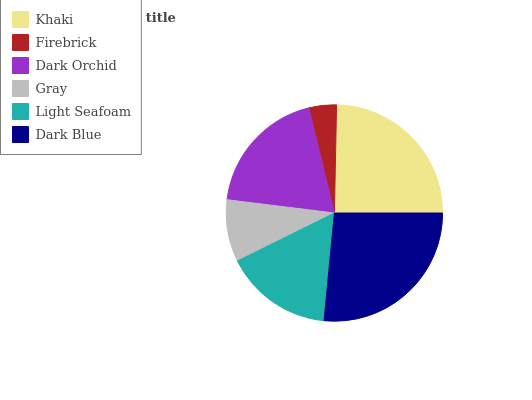Is Firebrick the minimum?
Answer yes or no. Yes. Is Dark Blue the maximum?
Answer yes or no. Yes. Is Dark Orchid the minimum?
Answer yes or no. No. Is Dark Orchid the maximum?
Answer yes or no. No. Is Dark Orchid greater than Firebrick?
Answer yes or no. Yes. Is Firebrick less than Dark Orchid?
Answer yes or no. Yes. Is Firebrick greater than Dark Orchid?
Answer yes or no. No. Is Dark Orchid less than Firebrick?
Answer yes or no. No. Is Dark Orchid the high median?
Answer yes or no. Yes. Is Light Seafoam the low median?
Answer yes or no. Yes. Is Gray the high median?
Answer yes or no. No. Is Dark Orchid the low median?
Answer yes or no. No. 